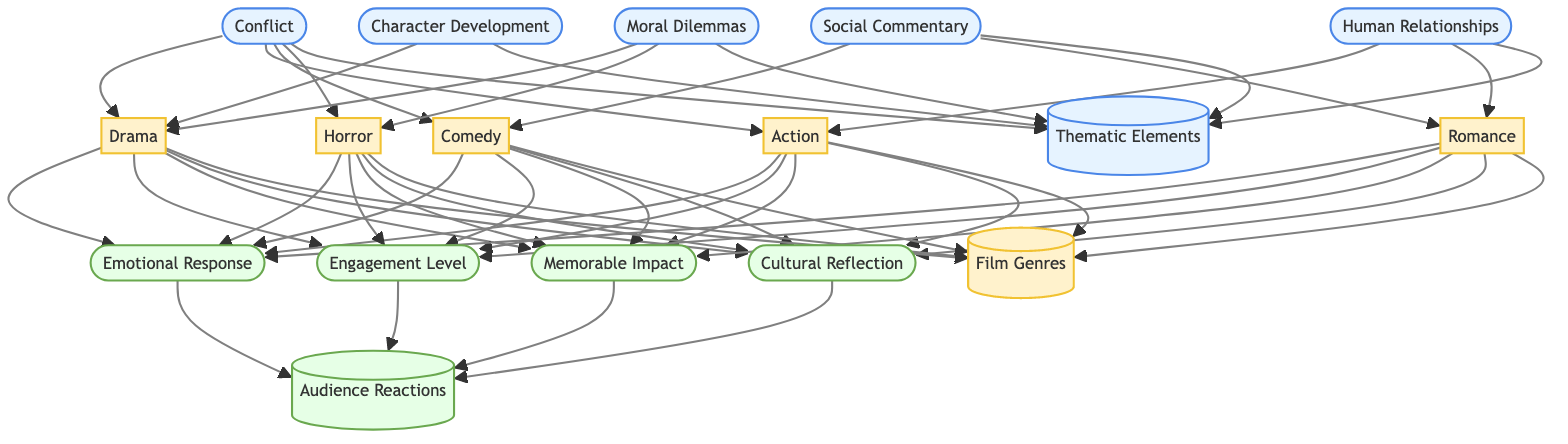What are the thematic elements represented in the diagram? The diagram lists five thematic elements: Conflict, Character Development, Moral Dilemmas, Social Commentary, and Human Relationships. Each of these thematic elements has direct connections to the film genres.
Answer: Conflict, Character Development, Moral Dilemmas, Social Commentary, Human Relationships How many film genres are depicted in the diagram? The diagram contains five film genres: Drama, Action, Comedy, Horror, and Romance. Each genre is tied to one or more thematic elements.
Answer: 5 Which film genre is associated with both Conflict and Human Relationships? The diagram connects the film genre Action with the thematic elements Conflict and Human Relationships. According to the connections in the diagram, Action relies on both aspects.
Answer: Action What audience reaction is common to all film genres in the diagram? The diagram shows that Emotional Response, Engagement Level, Memorable Impact, and Cultural Reflection are audience reactions linked to all listed film genres. The commonality lies in the connection stemming from all genres leading to these reactions.
Answer: Emotional Response, Engagement Level, Memorable Impact, Cultural Reflection Which thematic element is shared between Drama and Horror? The thematic element of Moral Dilemmas is directly connected to both the Drama and Horror film genres in the diagram, indicating that both genres explore this theme.
Answer: Moral Dilemmas How does the relationship of thematic elements to film genres manifest in audience reactions? The thematic elements contribute to the classification of film genres, which in turn leads to audience reactions. For example, Conflict (a thematic element) connects to multiple genres like Drama and Action, and thus influences audience reactions such as Emotional Response and Engagement Level.
Answer: Thematic elements lead to film genres, which influence audience reactions Which film genre involves Social Commentary as a thematic element? According to the diagram, Social Commentary is specifically associated with the film genres Comedy and Romance, making these two genres relevant for exploring this thematic element.
Answer: Comedy, Romance Which thematic element leads to the widest range of film genres? The thematic element Conflict links to four different film genres: Drama, Action, Comedy, and Horror. This range signifies its importance in various storytelling methods.
Answer: Conflict 